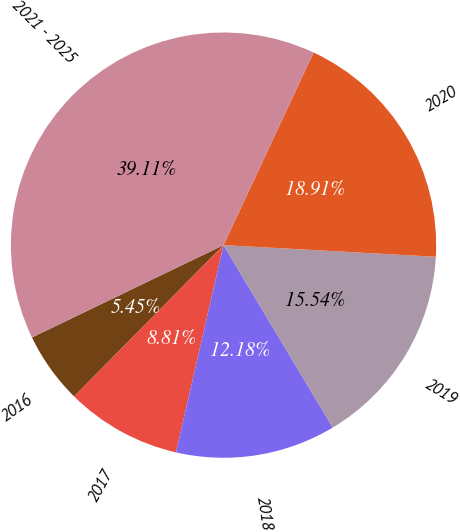<chart> <loc_0><loc_0><loc_500><loc_500><pie_chart><fcel>2016<fcel>2017<fcel>2018<fcel>2019<fcel>2020<fcel>2021 - 2025<nl><fcel>5.45%<fcel>8.81%<fcel>12.18%<fcel>15.54%<fcel>18.91%<fcel>39.11%<nl></chart> 